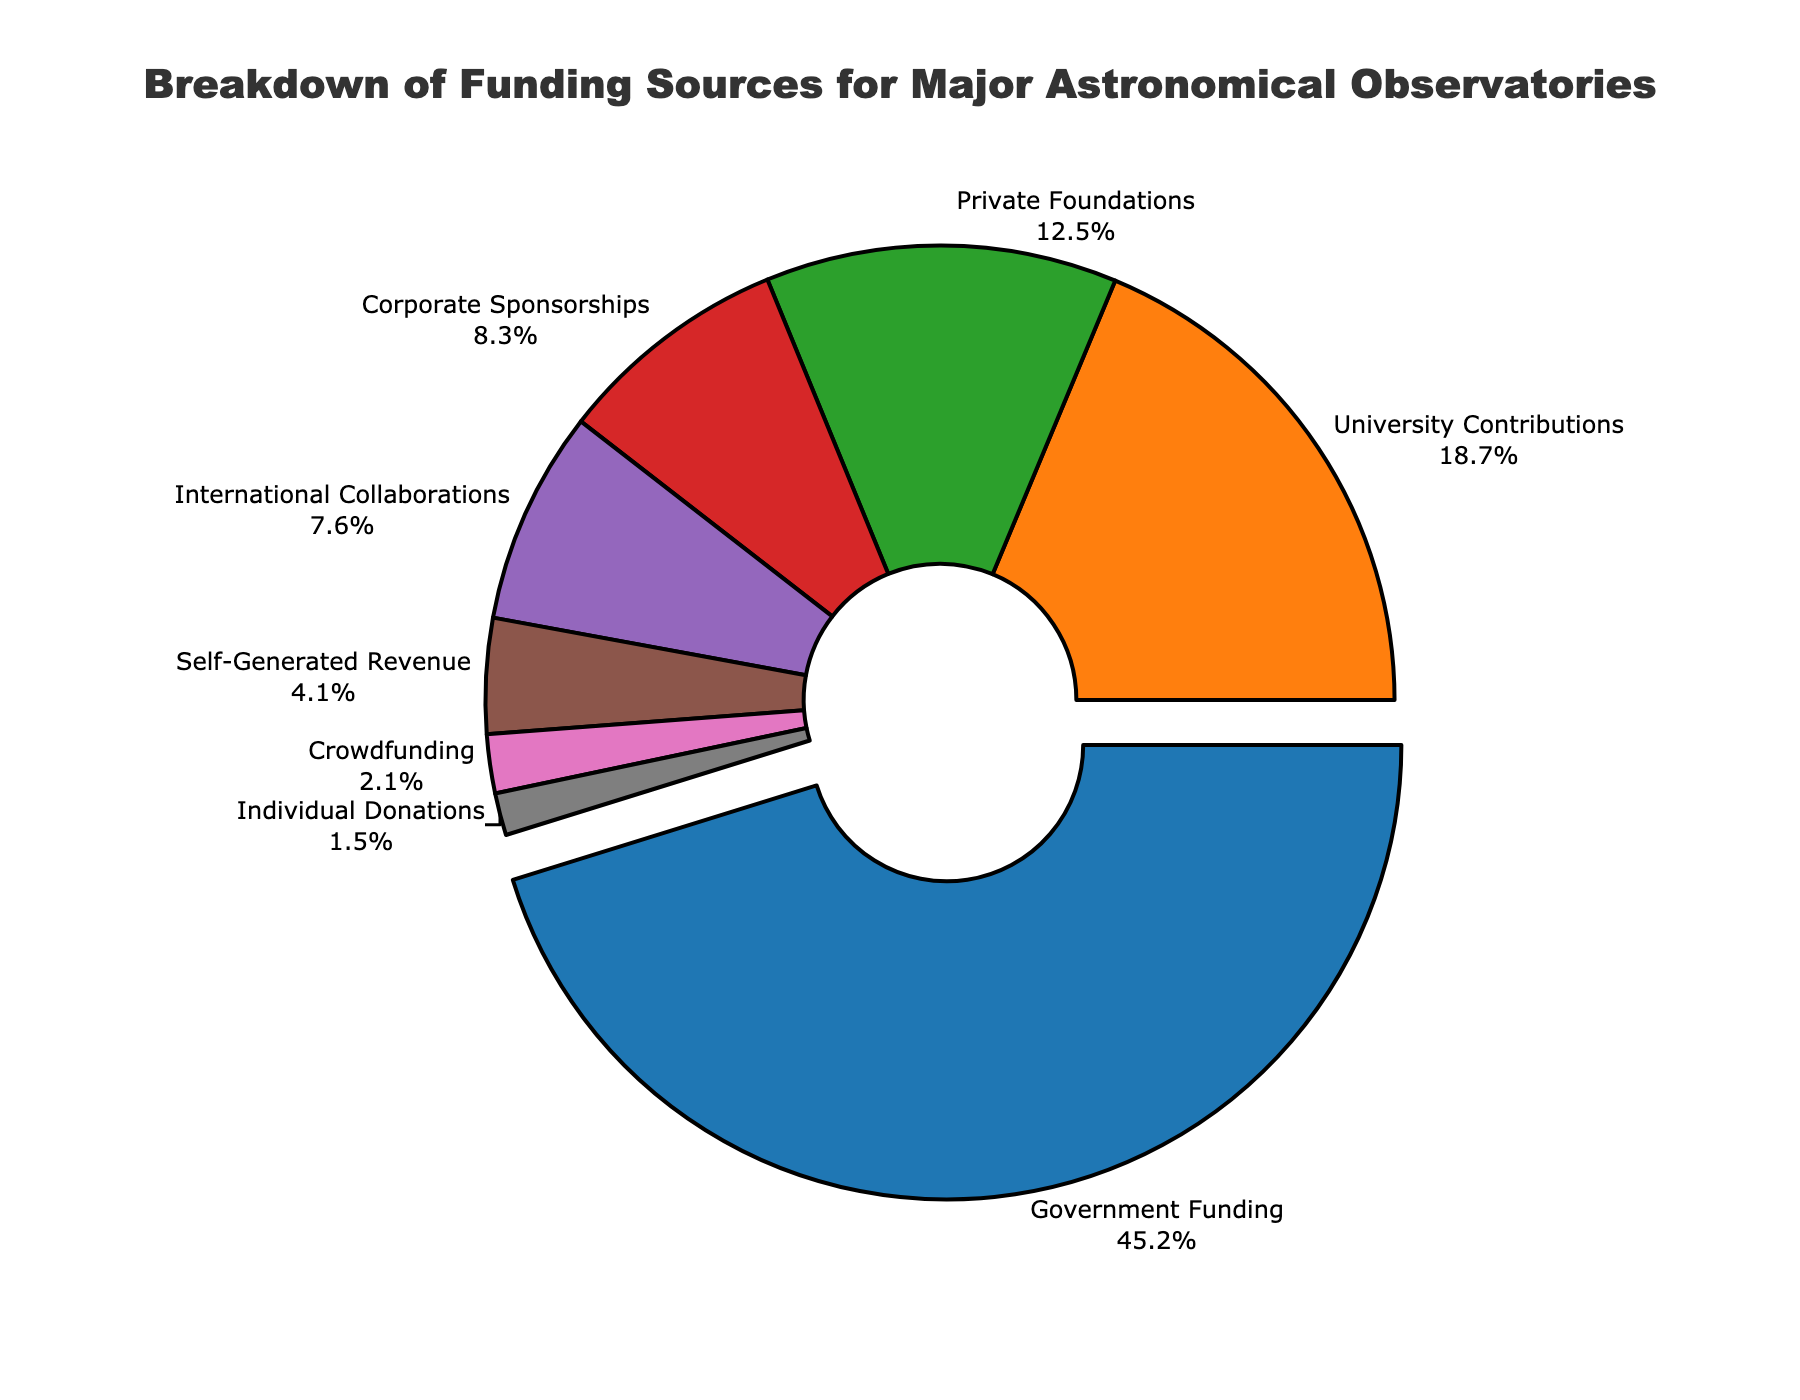Which funding source contributes the most to major astronomical observatories? To identify the funding source that contributes the most, look for the segment with the largest percentage. In the pie chart, "Government Funding" has the largest slice, indicated by the percentage 45.2%.
Answer: Government Funding Which two funding sources together make up more than 50% of the funding? To determine which two sources add up to more than 50%, find the two largest percentages and sum them. "Government Funding" is 45.2% and "University Contributions" is 18.7%. Their sum is 63.9%, which is more than 50%.
Answer: Government Funding and University Contributions What is the combined percentage of funding from private foundations and individual donations? Sum the percentages for "Private Foundations" and "Individual Donations": 12.5% + 1.5% = 14.0%.
Answer: 14.0% Which funding source has the smallest percentage? Identify the segment with the smallest percentage in the pie chart. "Individual Donations" have the smallest segment with 1.5%.
Answer: Individual Donations What is the difference in percentage between corporate sponsorships and international collaborations? Subtract the percentage of "International Collaborations" from "Corporate Sponsorships": 8.3% - 7.6% = 0.7%.
Answer: 0.7% How do university contributions compare to self-generated revenue? Compare the percentages for "University Contributions" (18.7%) and "Self-Generated Revenue" (4.1%). University contributions are significantly higher.
Answer: University contributions are higher If we were to group private foundations, corporate sponsorships, and individual donations together, what would be their total contribution percentage? Sum the percentages for "Private Foundations", "Corporate Sponsorships", and "Individual Donations": 12.5% + 8.3% + 1.5% = 22.3%.
Answer: 22.3% What color represents international collaborations on the pie chart? Locate "International Collaborations" on the pie chart and identify its color. "International Collaborations" is represented by the fifth slice, colored in purple.
Answer: Purple Among the sources listed, which two categories have the closest contribution percentages? Compare the percentages of all funding sources to find the closest values. "Corporate Sponsorships" (8.3%) and "International Collaborations" (7.6%) are the closest, with a difference of only 0.7%.
Answer: Corporate Sponsorships and International Collaborations How much more does government funding contribute compared to crowdfunding? Subtract the percentage of "Crowdfunding" from "Government Funding": 45.2% - 2.1% = 43.1%.
Answer: 43.1% 